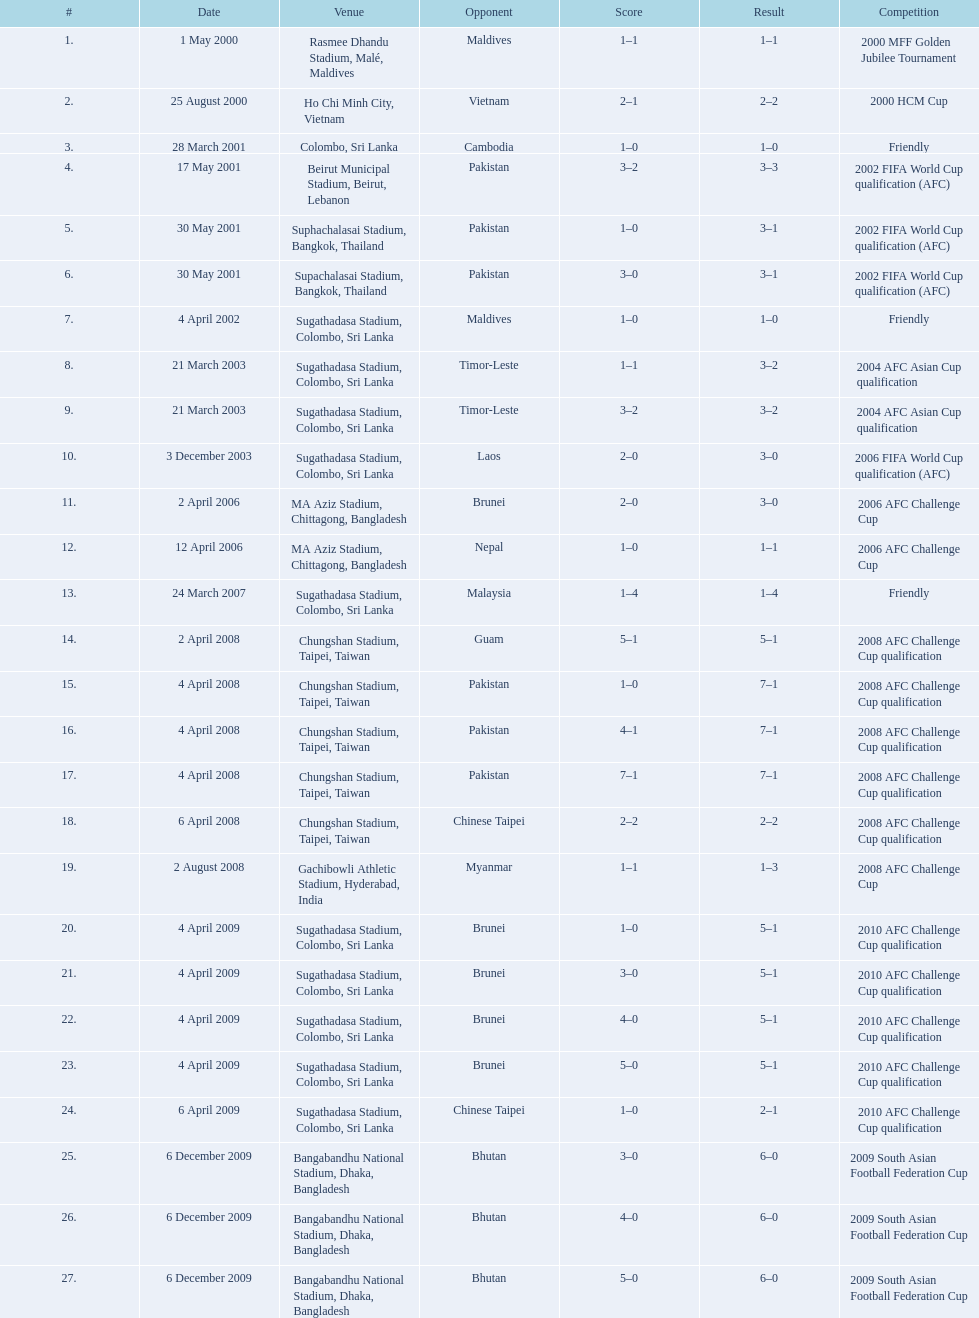How many locations are in the table? 27. Which one is the highest listed? Rasmee Dhandu Stadium, Malé, Maldives. 